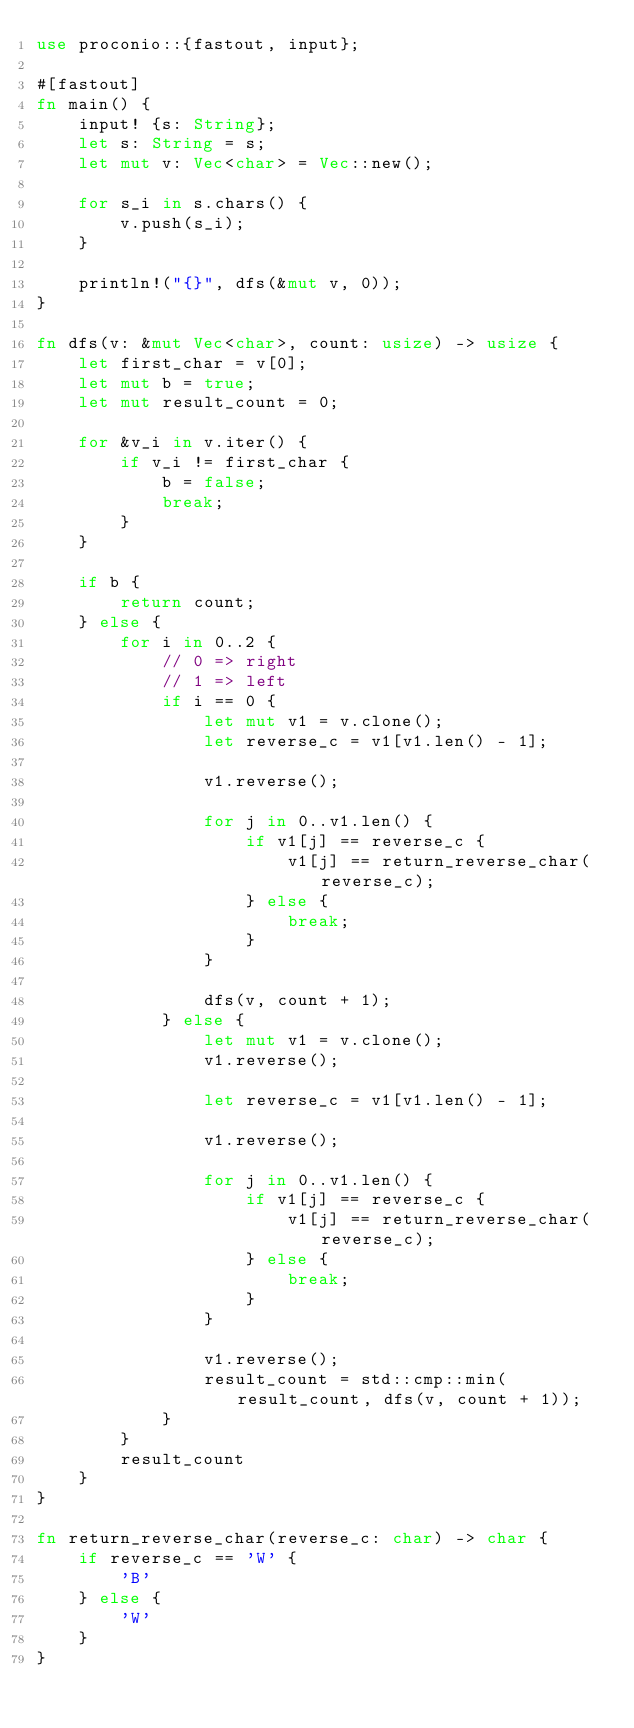Convert code to text. <code><loc_0><loc_0><loc_500><loc_500><_Rust_>use proconio::{fastout, input};

#[fastout]
fn main() {
    input! {s: String};
    let s: String = s;
    let mut v: Vec<char> = Vec::new();

    for s_i in s.chars() {
        v.push(s_i);
    }

    println!("{}", dfs(&mut v, 0));
}

fn dfs(v: &mut Vec<char>, count: usize) -> usize {
    let first_char = v[0];
    let mut b = true;
    let mut result_count = 0;

    for &v_i in v.iter() {
        if v_i != first_char {
            b = false;
            break;
        }
    }

    if b {
        return count;
    } else {
        for i in 0..2 {
            // 0 => right
            // 1 => left
            if i == 0 {
                let mut v1 = v.clone();
                let reverse_c = v1[v1.len() - 1];

                v1.reverse();

                for j in 0..v1.len() {
                    if v1[j] == reverse_c {
                        v1[j] == return_reverse_char(reverse_c);
                    } else {
                        break;
                    }
                }

                dfs(v, count + 1);
            } else {
                let mut v1 = v.clone();
                v1.reverse();

                let reverse_c = v1[v1.len() - 1];

                v1.reverse();

                for j in 0..v1.len() {
                    if v1[j] == reverse_c {
                        v1[j] == return_reverse_char(reverse_c);
                    } else {
                        break;
                    }
                }

                v1.reverse();
                result_count = std::cmp::min(result_count, dfs(v, count + 1));
            }
        }
        result_count
    }
}

fn return_reverse_char(reverse_c: char) -> char {
    if reverse_c == 'W' {
        'B'
    } else {
        'W'
    }
}
</code> 